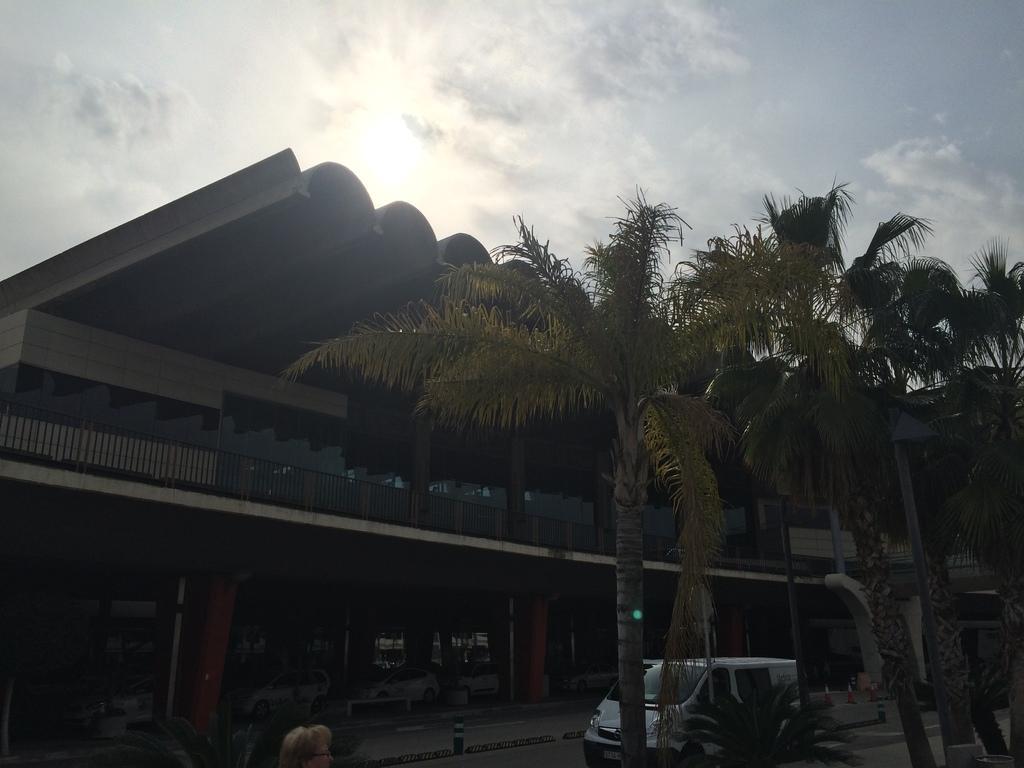How would you summarize this image in a sentence or two? In this picture we can see the building. At the bottom we can see van which is parked near to the trees. In the bottom left there is a woman. At the top we can see sky, clouds and sun. 